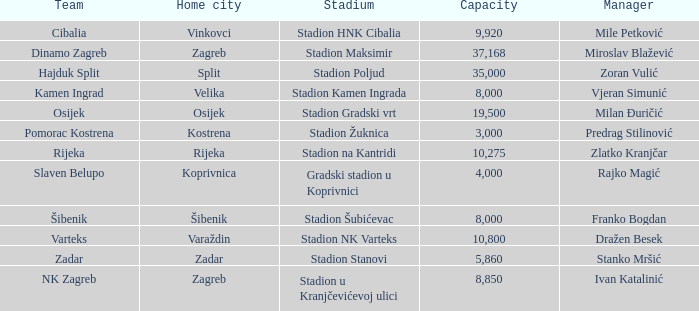What team has a home city of Velika? Kamen Ingrad. 